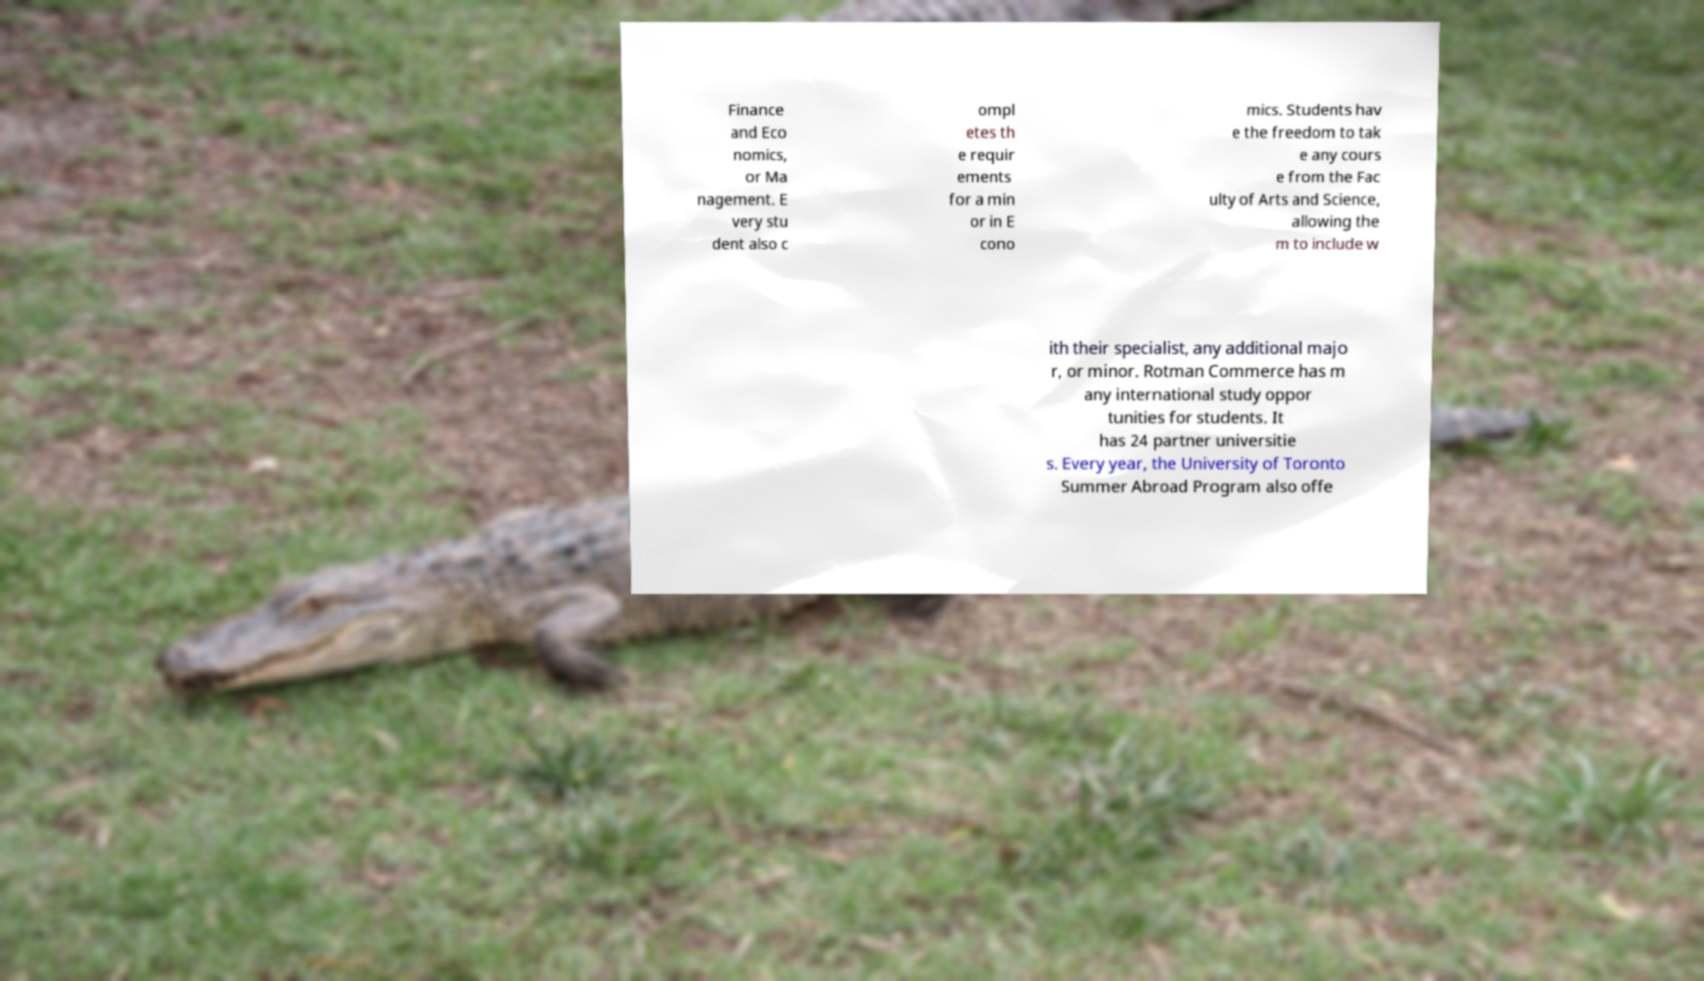For documentation purposes, I need the text within this image transcribed. Could you provide that? Finance and Eco nomics, or Ma nagement. E very stu dent also c ompl etes th e requir ements for a min or in E cono mics. Students hav e the freedom to tak e any cours e from the Fac ulty of Arts and Science, allowing the m to include w ith their specialist, any additional majo r, or minor. Rotman Commerce has m any international study oppor tunities for students. It has 24 partner universitie s. Every year, the University of Toronto Summer Abroad Program also offe 